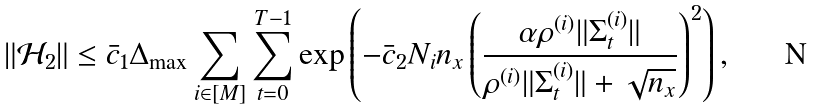<formula> <loc_0><loc_0><loc_500><loc_500>\| \mathcal { H } _ { 2 } \| \leq \bar { c } _ { 1 } \Delta _ { \max } \sum _ { i \in [ M ] } \sum _ { t = 0 } ^ { T - 1 } \exp \left ( - \bar { c } _ { 2 } N _ { i } n _ { x } \left ( \frac { \alpha \rho ^ { ( i ) } \| \Sigma ^ { ( i ) } _ { t } \| } { \rho ^ { ( i ) } \| \Sigma ^ { ( i ) } _ { t } \| + \sqrt { n _ { x } } } \right ) ^ { 2 } \right ) ,</formula> 